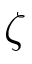<formula> <loc_0><loc_0><loc_500><loc_500>\zeta</formula> 